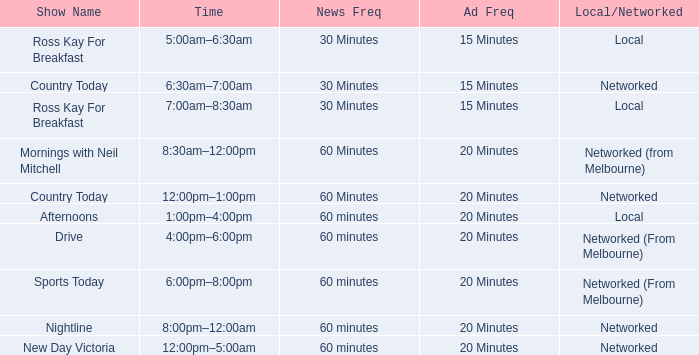Parse the full table. {'header': ['Show Name', 'Time', 'News Freq', 'Ad Freq', 'Local/Networked'], 'rows': [['Ross Kay For Breakfast', '5:00am–6:30am', '30 Minutes', '15 Minutes', 'Local'], ['Country Today', '6:30am–7:00am', '30 Minutes', '15 Minutes', 'Networked'], ['Ross Kay For Breakfast', '7:00am–8:30am', '30 Minutes', '15 Minutes', 'Local'], ['Mornings with Neil Mitchell', '8:30am–12:00pm', '60 Minutes', '20 Minutes', 'Networked (from Melbourne)'], ['Country Today', '12:00pm–1:00pm', '60 Minutes', '20 Minutes', 'Networked'], ['Afternoons', '1:00pm–4:00pm', '60 minutes', '20 Minutes', 'Local'], ['Drive', '4:00pm–6:00pm', '60 minutes', '20 Minutes', 'Networked (From Melbourne)'], ['Sports Today', '6:00pm–8:00pm', '60 minutes', '20 Minutes', 'Networked (From Melbourne)'], ['Nightline', '8:00pm–12:00am', '60 minutes', '20 Minutes', 'Networked'], ['New Day Victoria', '12:00pm–5:00am', '60 minutes', '20 Minutes', 'Networked']]} What Time has a Show Name of mornings with neil mitchell? 8:30am–12:00pm. 